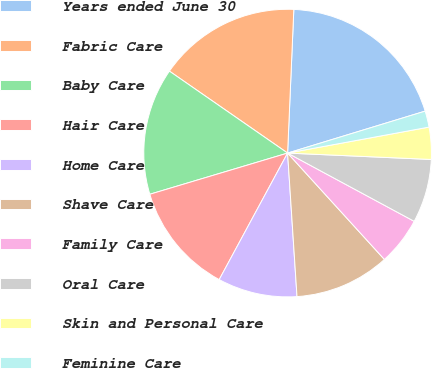<chart> <loc_0><loc_0><loc_500><loc_500><pie_chart><fcel>Years ended June 30<fcel>Fabric Care<fcel>Baby Care<fcel>Hair Care<fcel>Home Care<fcel>Shave Care<fcel>Family Care<fcel>Oral Care<fcel>Skin and Personal Care<fcel>Feminine Care<nl><fcel>19.6%<fcel>16.04%<fcel>14.27%<fcel>12.49%<fcel>8.93%<fcel>10.71%<fcel>5.38%<fcel>7.16%<fcel>3.6%<fcel>1.82%<nl></chart> 